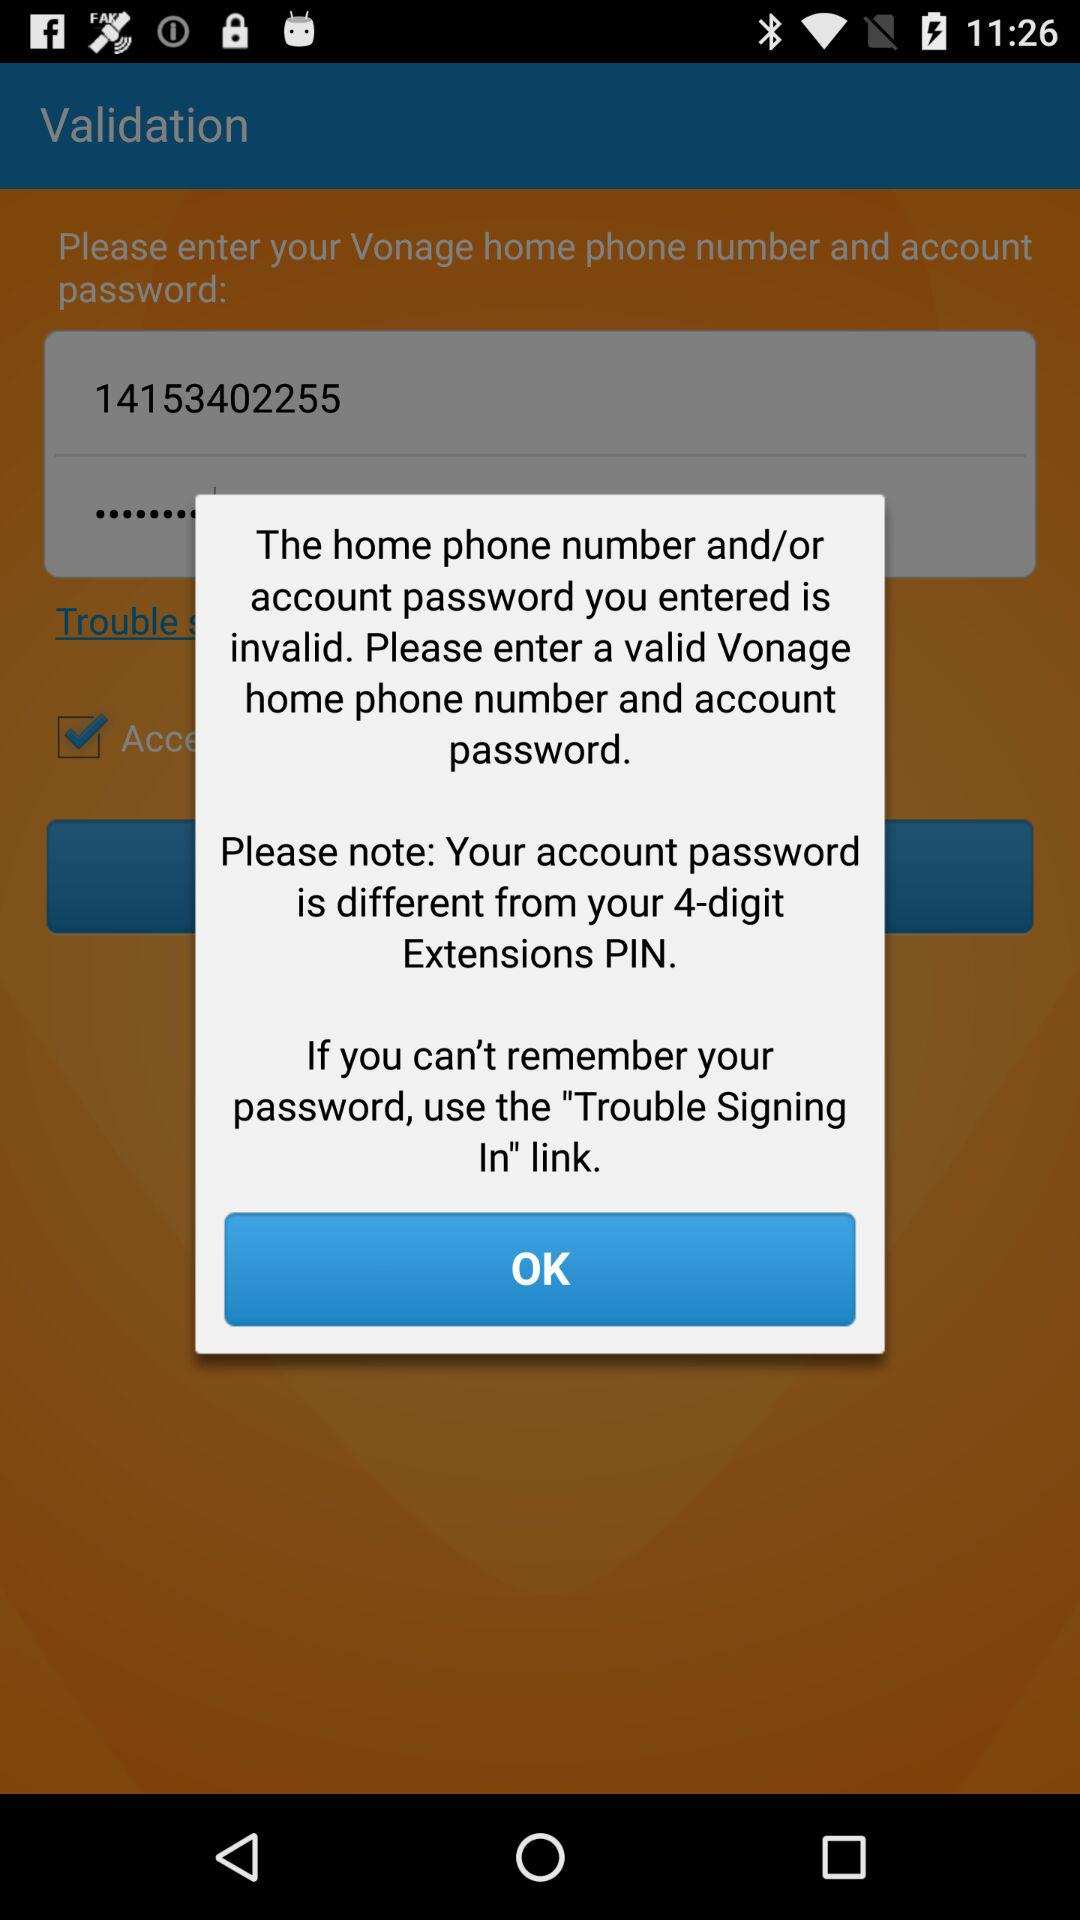What is the phone number? The phone number is 14153402255. 